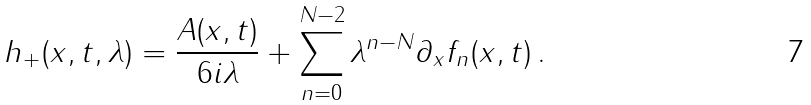Convert formula to latex. <formula><loc_0><loc_0><loc_500><loc_500>h _ { + } ( x , t , \lambda ) = \frac { A ( x , t ) } { 6 i \lambda } + \sum _ { n = 0 } ^ { N - 2 } \lambda ^ { n - N } \partial _ { x } f _ { n } ( x , t ) \, .</formula> 